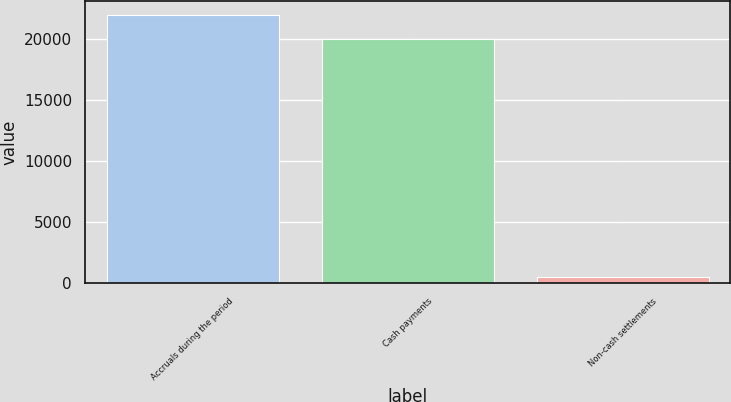Convert chart. <chart><loc_0><loc_0><loc_500><loc_500><bar_chart><fcel>Accruals during the period<fcel>Cash payments<fcel>Non-cash settlements<nl><fcel>21972.5<fcel>19975<fcel>564<nl></chart> 